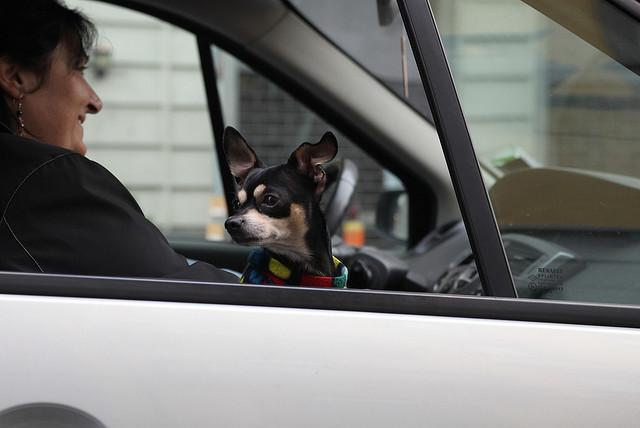How many dogs are in the photo?
Give a very brief answer. 1. How many giraffe are in the picture?
Give a very brief answer. 0. 